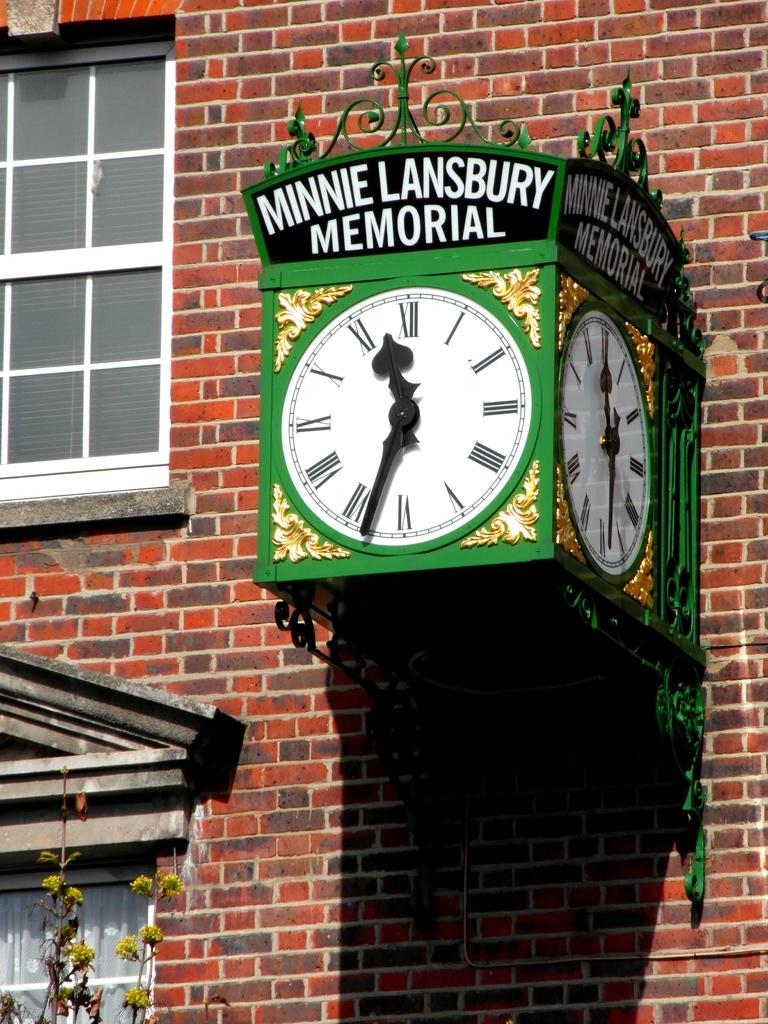Provide a one-sentence caption for the provided image. A green clock reading "Minnie Lansubury Memorial" sticks out of a brick building. 